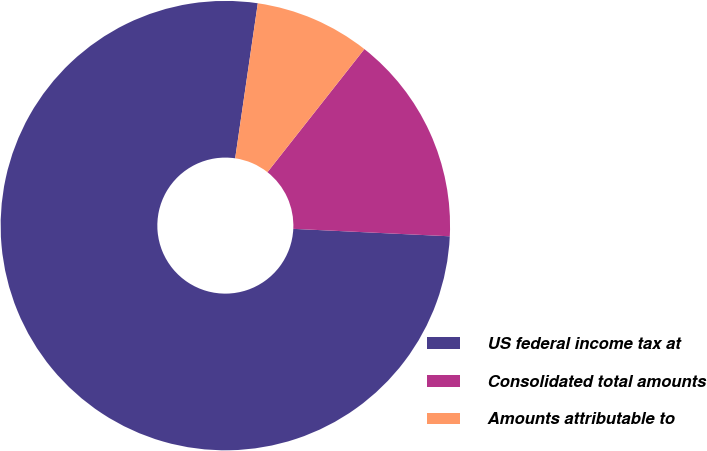Convert chart to OTSL. <chart><loc_0><loc_0><loc_500><loc_500><pie_chart><fcel>US federal income tax at<fcel>Consolidated total amounts<fcel>Amounts attributable to<nl><fcel>76.55%<fcel>15.14%<fcel>8.31%<nl></chart> 